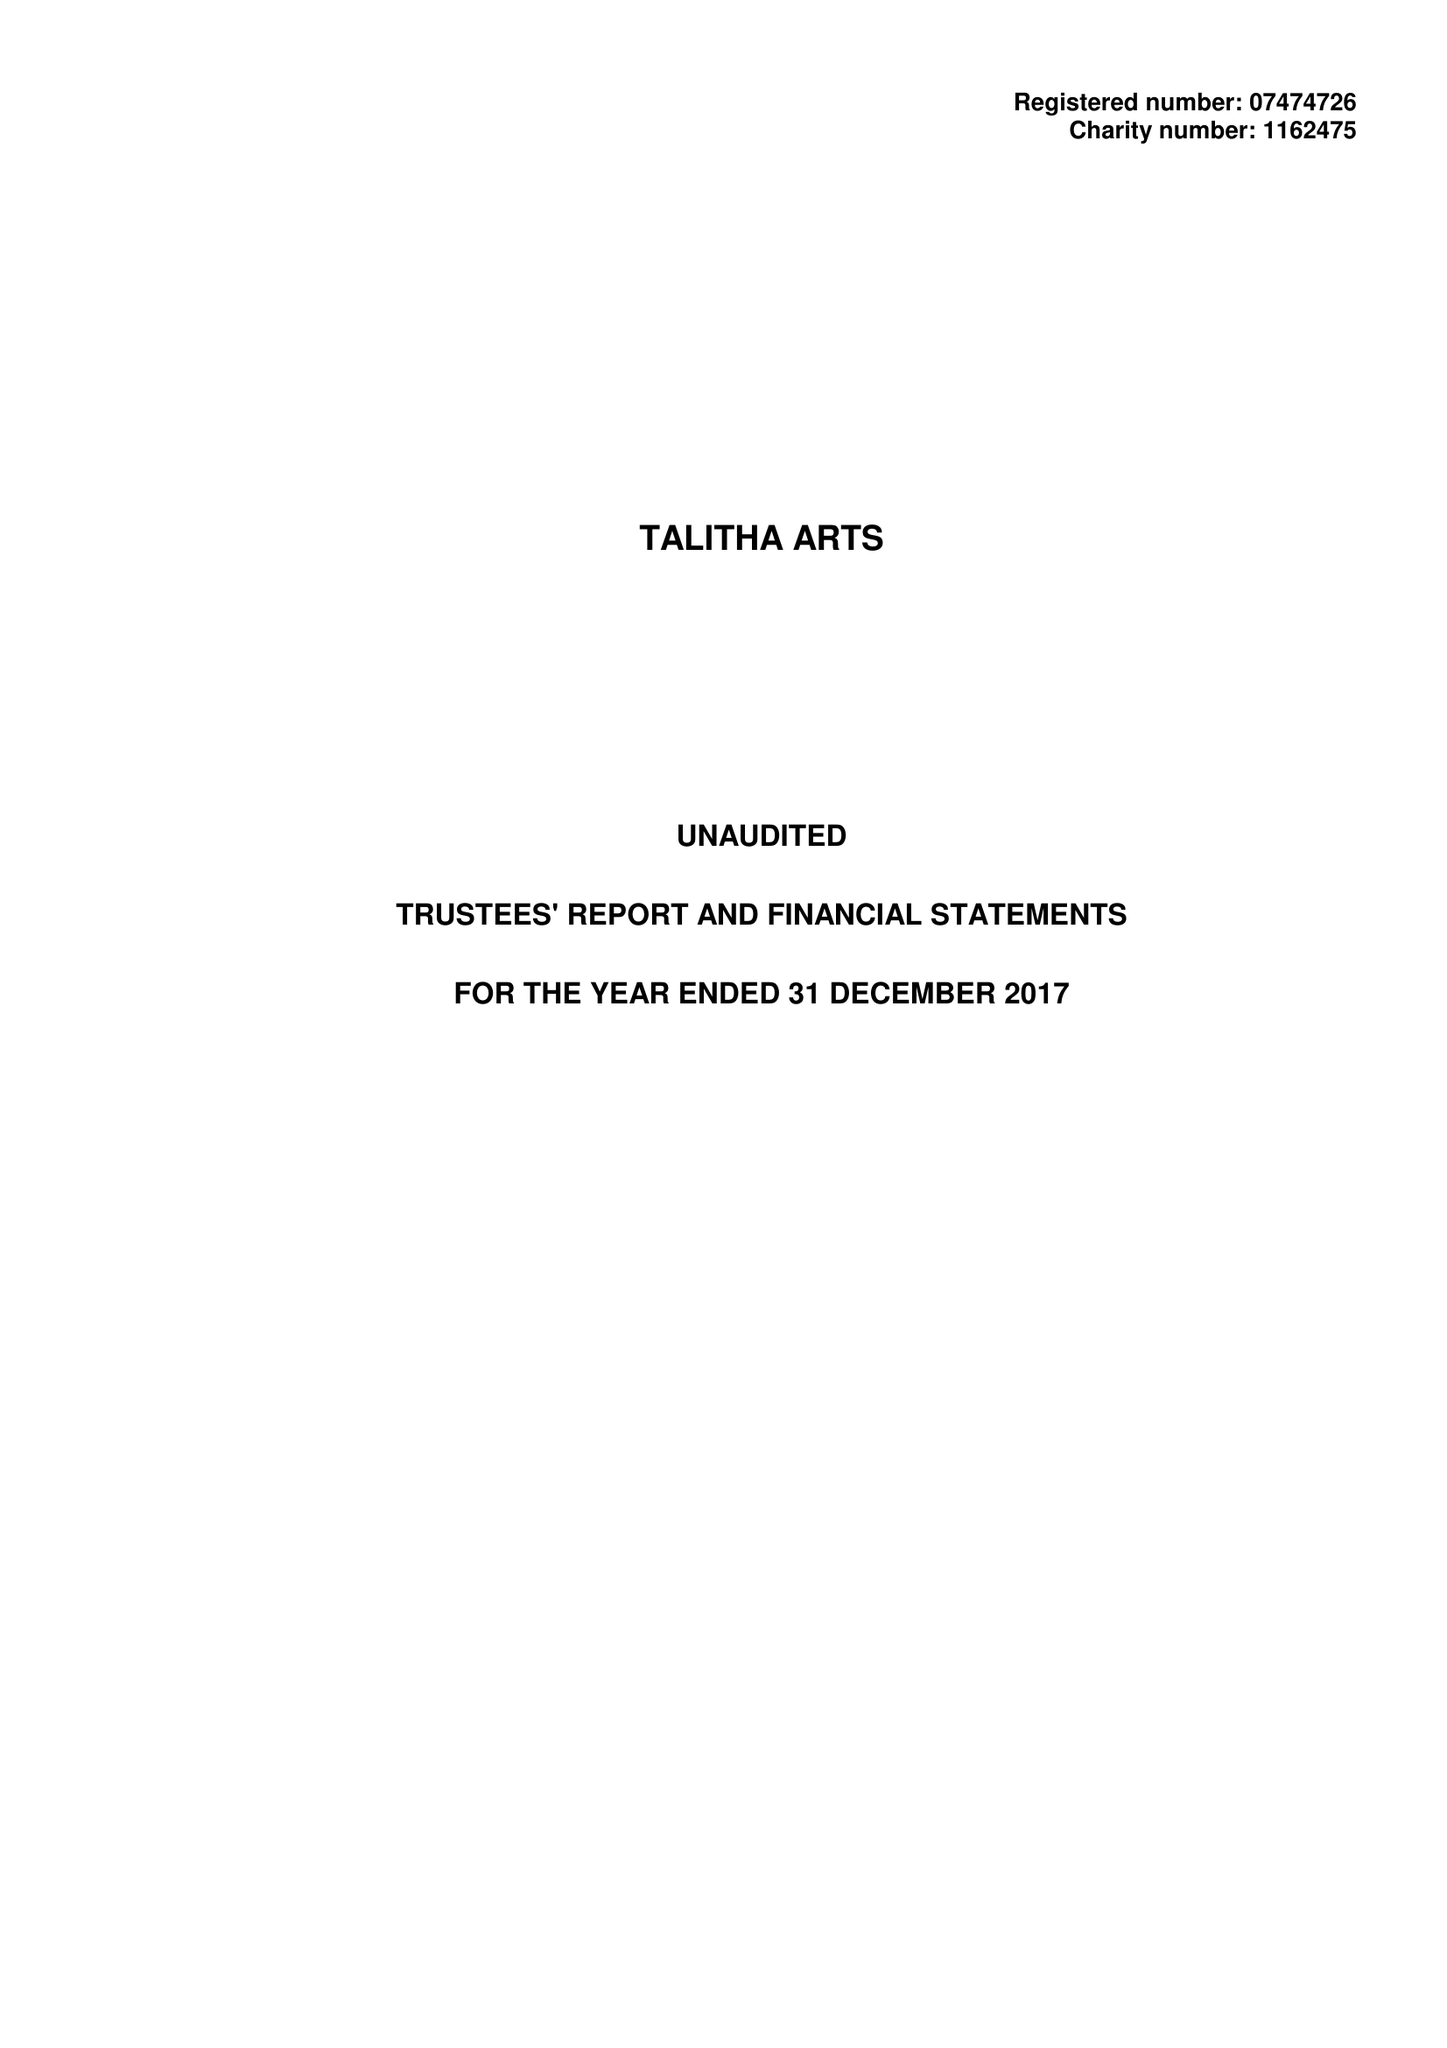What is the value for the address__postcode?
Answer the question using a single word or phrase. TW11 0BQ 